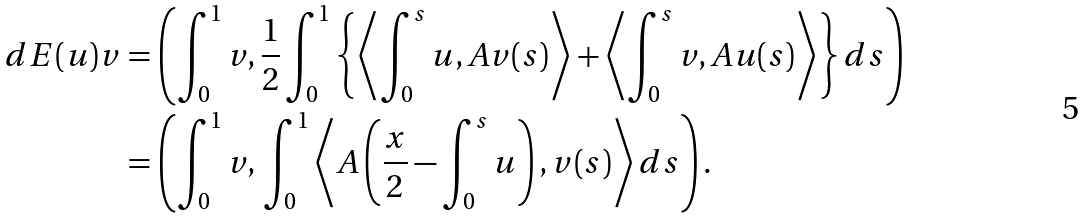<formula> <loc_0><loc_0><loc_500><loc_500>d E ( u ) v & = \left ( \int _ { 0 } ^ { 1 } v , \frac { 1 } { 2 } \int _ { 0 } ^ { 1 } \left \{ \left \langle \int _ { 0 } ^ { s } u , A v ( s ) \right \rangle + \left \langle \int _ { 0 } ^ { s } v , A u ( s ) \right \rangle \right \} d s \right ) \\ & = \left ( \int _ { 0 } ^ { 1 } v , \, \int _ { 0 } ^ { 1 } \left \langle A \left ( \frac { x } { 2 } - \int _ { 0 } ^ { s } u \right ) , v ( s ) \right \rangle d s \right ) .</formula> 